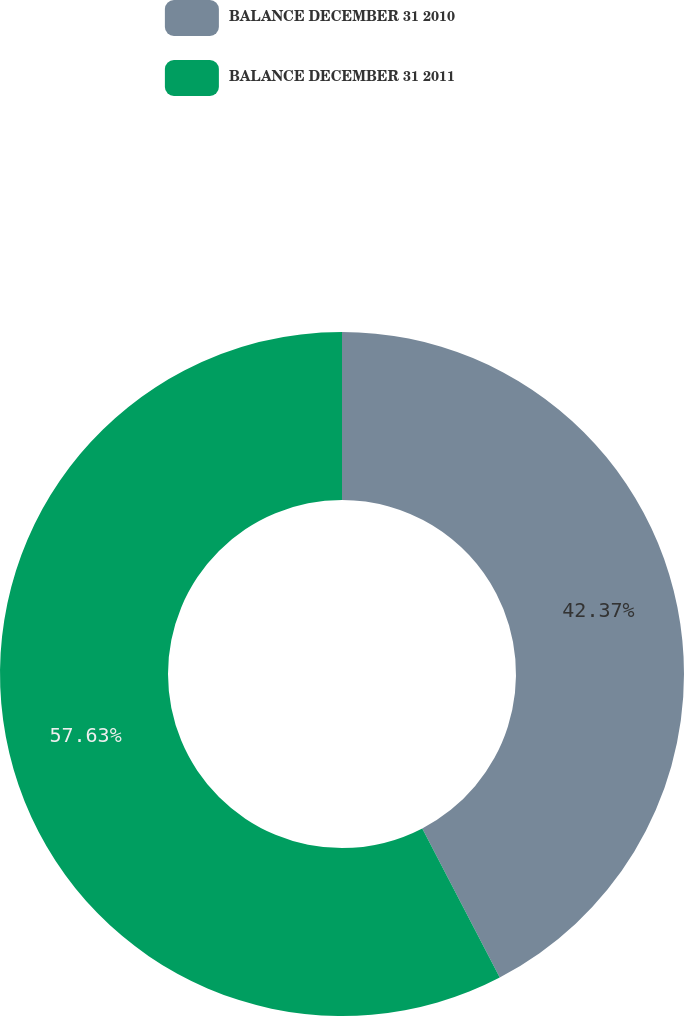Convert chart to OTSL. <chart><loc_0><loc_0><loc_500><loc_500><pie_chart><fcel>BALANCE DECEMBER 31 2010<fcel>BALANCE DECEMBER 31 2011<nl><fcel>42.37%<fcel>57.63%<nl></chart> 